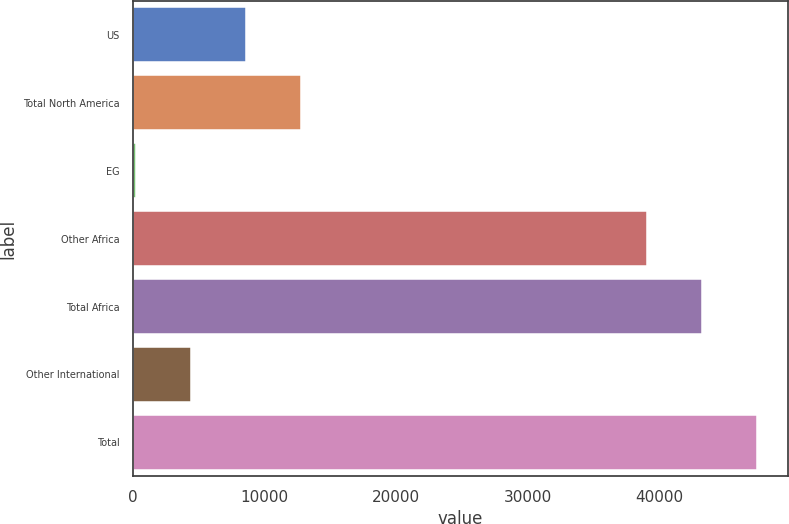Convert chart. <chart><loc_0><loc_0><loc_500><loc_500><bar_chart><fcel>US<fcel>Total North America<fcel>EG<fcel>Other Africa<fcel>Total Africa<fcel>Other International<fcel>Total<nl><fcel>8579<fcel>12754.5<fcel>228<fcel>39054<fcel>43229.5<fcel>4403.5<fcel>47405<nl></chart> 